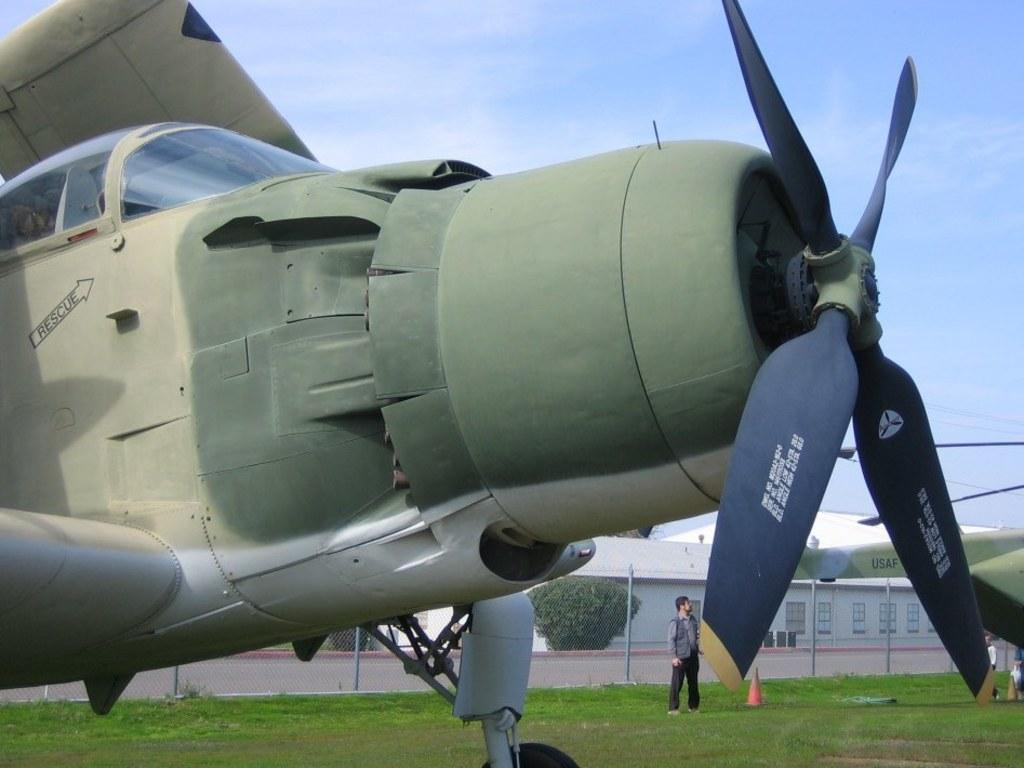<image>
Write a terse but informative summary of the picture. An army green prop plane on a grass field has an arrow pointing to the front that reads "rescue". 